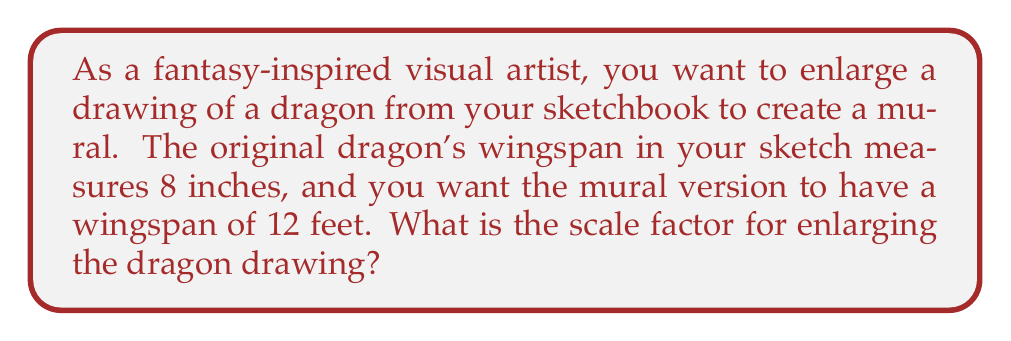Could you help me with this problem? To find the scale factor, we need to compare the new size to the original size. Let's approach this step-by-step:

1. Convert all measurements to the same unit:
   Original wingspan = 8 inches
   Desired wingspan = 12 feet = 12 × 12 = 144 inches

2. Set up the scale factor equation:
   $\text{Scale factor} = \frac{\text{New size}}{\text{Original size}}$

3. Substitute the values:
   $\text{Scale factor} = \frac{144 \text{ inches}}{8 \text{ inches}}$

4. Simplify the fraction:
   $\text{Scale factor} = \frac{144}{8} = 18$

Therefore, the scale factor for enlarging the dragon drawing is 18, meaning each dimension of the original drawing will be multiplied by 18 to create the mural version.
Answer: 18 